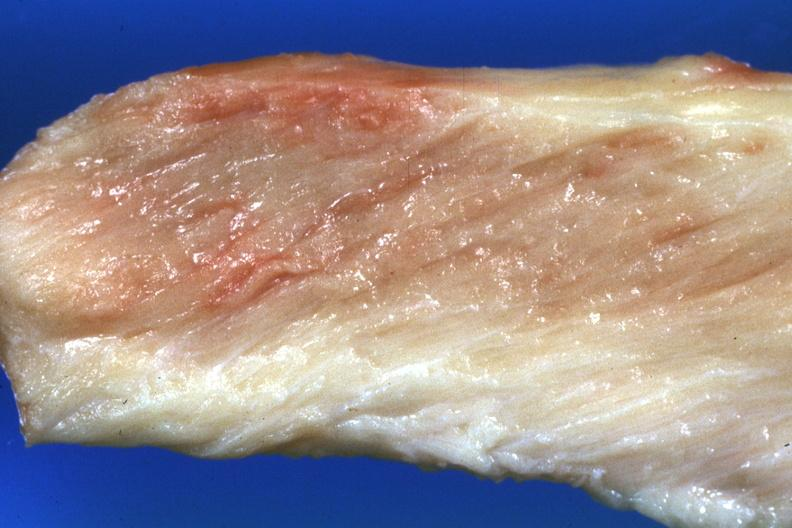what pale muscle?
Answer the question using a single word or phrase. Close-up view 